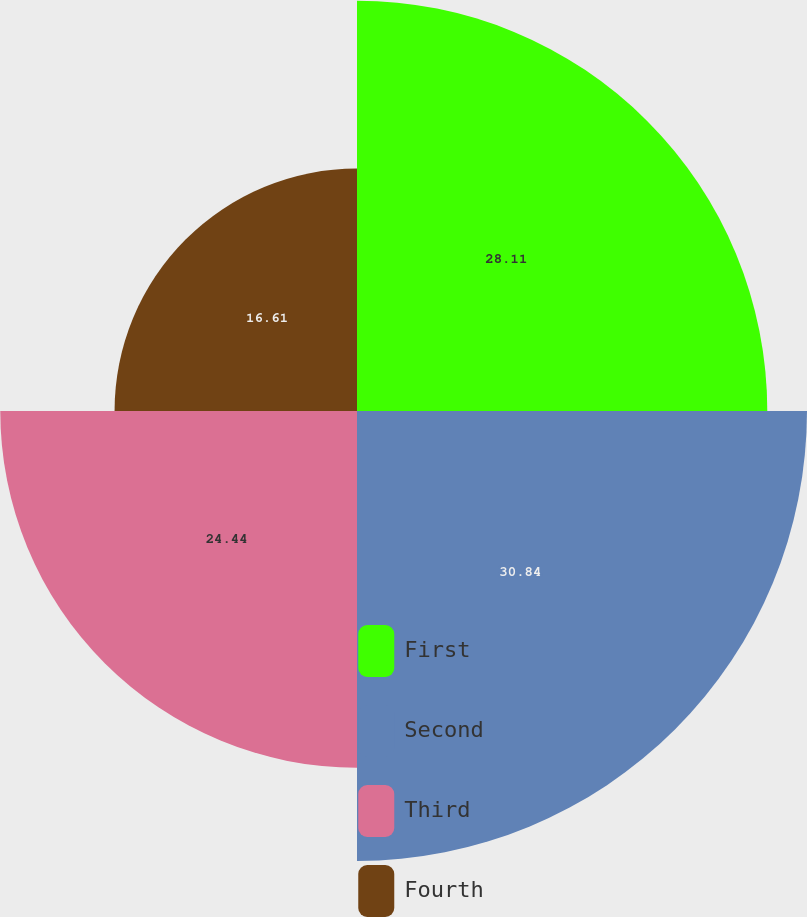<chart> <loc_0><loc_0><loc_500><loc_500><pie_chart><fcel>First<fcel>Second<fcel>Third<fcel>Fourth<nl><fcel>28.11%<fcel>30.83%<fcel>24.44%<fcel>16.61%<nl></chart> 